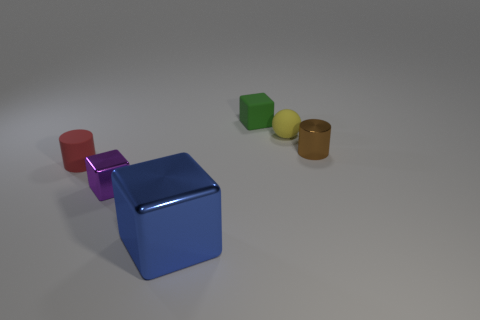There is a matte thing in front of the brown cylinder; is it the same size as the blue cube in front of the small yellow ball?
Keep it short and to the point. No. How many objects are either small things behind the purple metal object or green rubber objects?
Your answer should be very brief. 4. What number of other things are there of the same material as the tiny brown object
Ensure brevity in your answer.  2. What size is the rubber object that is to the right of the small rubber cube?
Your response must be concise. Small. There is a green thing that is made of the same material as the small yellow sphere; what is its shape?
Keep it short and to the point. Cube. Does the green object have the same material as the tiny cylinder that is to the left of the green rubber cube?
Offer a very short reply. Yes. There is a tiny shiny object that is left of the big shiny block; is its shape the same as the small green matte thing?
Your response must be concise. Yes. There is a purple thing that is the same shape as the green matte object; what is its material?
Provide a succinct answer. Metal. Do the tiny brown metallic object and the small rubber thing that is left of the purple cube have the same shape?
Give a very brief answer. Yes. There is a tiny thing that is on the right side of the small green thing and behind the brown cylinder; what is its color?
Give a very brief answer. Yellow. 